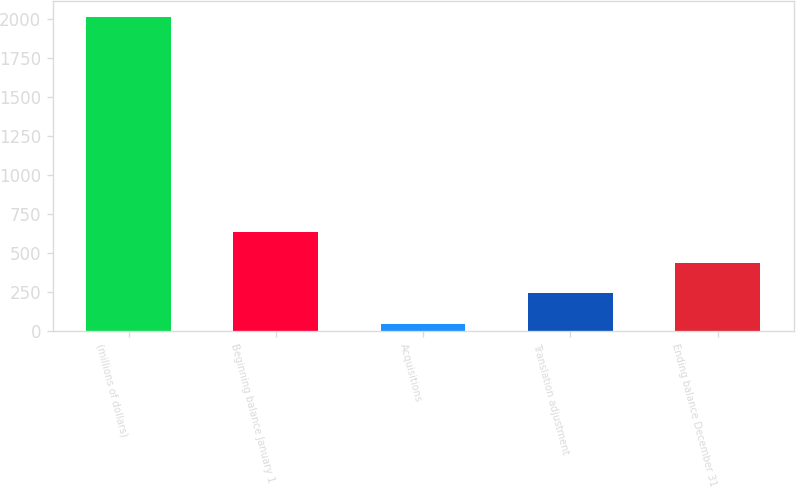<chart> <loc_0><loc_0><loc_500><loc_500><bar_chart><fcel>(millions of dollars)<fcel>Beginning balance January 1<fcel>Acquisitions<fcel>Translation adjustment<fcel>Ending balance December 31<nl><fcel>2014<fcel>634.09<fcel>42.7<fcel>239.83<fcel>436.96<nl></chart> 